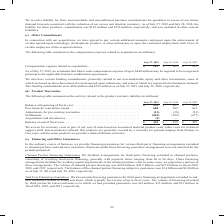According to Cisco Systems's financial document, How does the company accrue for warranty costs? as part of our cost of sales based on associated material product costs, labor costs for technical support staff, and associated overhead. The document states: "We accrue for warranty costs as part of our cost of sales based on associated material product costs, labor costs for technical support staff, and ass..." Also, Which years does the table provide information for the company's activity related to their product warranty liability? The document contains multiple relevant values: 2019, 2018, 2017. From the document: "July 27, 2019 July 28, 2018 July 29, 2017 Compensation expense related to acquisitions � � � � � � � � � � � � � � � � � � � � � � � � � � � July 27, ..." Also, What were the Acquisitions and divestitures in 2019? According to the financial document, (2) (in millions). The relevant text states: "� � � � � � � � � � � � � � � � � � � � � � � � � (2) — — Balance at end of fiscal year � � � � � � � � � � � � � � � � � � � � � � � � � � � � � � � � �..." Also, can you calculate: What was the change in Provisions for warranties issued between 2017 and 2018? Based on the calculation: 582-691, the result is -109 (in millions). This is based on the information: "� � � � � � � � � � � � � � � � � � � � � 600 582 691 Adjustments for pre-existing warranties � � � � � � � � � � � � � � � � � � � � � � � � � � � � � � � � � � � � � � � � � � � � � � � � � � � � � ..." The key data points involved are: 582, 691. Also, How many years did the Balance at beginning of fiscal year exceed $400 million? Counting the relevant items in the document: 2018, 2017, I find 2 instances. The key data points involved are: 2017, 2018. Also, can you calculate: What was the percentage change in the Balance at end of fiscal year between 2018 and 2019? To answer this question, I need to perform calculations using the financial data. The calculation is: (342-359)/359, which equals -4.74 (percentage). This is based on the information: "� � � � � � � � � � � � � � � � � � � � � � � � $ 342 $ 359 $ 407 � � � � � � � � � � � � � � � � � � � � � � � � $ 359 $ 407 $ 414 Provisions for warranties issued � � � � � � � � � � � � � � � � � �..." The key data points involved are: 342, 359. 